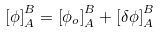Convert formula to latex. <formula><loc_0><loc_0><loc_500><loc_500>\left [ \phi \right ] _ { A } ^ { B } = \left [ \phi _ { o } \right ] _ { A } ^ { B } + \left [ \delta \phi \right ] _ { A } ^ { B }</formula> 